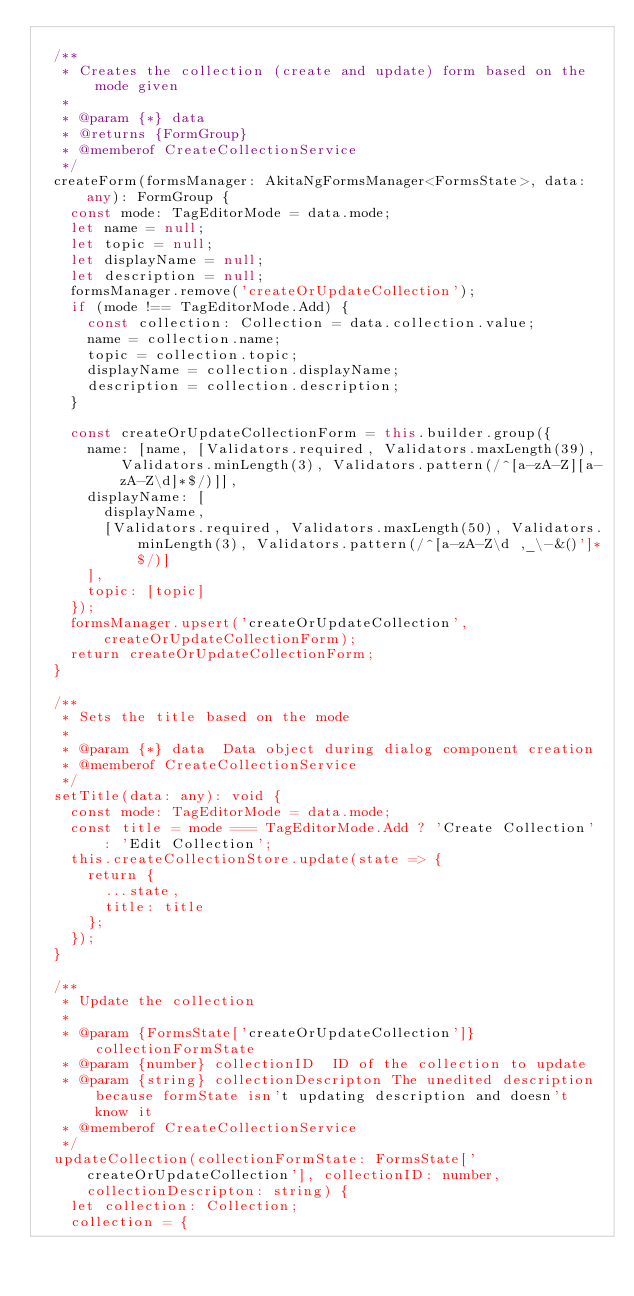<code> <loc_0><loc_0><loc_500><loc_500><_TypeScript_>
  /**
   * Creates the collection (create and update) form based on the mode given
   *
   * @param {*} data
   * @returns {FormGroup}
   * @memberof CreateCollectionService
   */
  createForm(formsManager: AkitaNgFormsManager<FormsState>, data: any): FormGroup {
    const mode: TagEditorMode = data.mode;
    let name = null;
    let topic = null;
    let displayName = null;
    let description = null;
    formsManager.remove('createOrUpdateCollection');
    if (mode !== TagEditorMode.Add) {
      const collection: Collection = data.collection.value;
      name = collection.name;
      topic = collection.topic;
      displayName = collection.displayName;
      description = collection.description;
    }

    const createOrUpdateCollectionForm = this.builder.group({
      name: [name, [Validators.required, Validators.maxLength(39), Validators.minLength(3), Validators.pattern(/^[a-zA-Z][a-zA-Z\d]*$/)]],
      displayName: [
        displayName,
        [Validators.required, Validators.maxLength(50), Validators.minLength(3), Validators.pattern(/^[a-zA-Z\d ,_\-&()']*$/)]
      ],
      topic: [topic]
    });
    formsManager.upsert('createOrUpdateCollection', createOrUpdateCollectionForm);
    return createOrUpdateCollectionForm;
  }

  /**
   * Sets the title based on the mode
   *
   * @param {*} data  Data object during dialog component creation
   * @memberof CreateCollectionService
   */
  setTitle(data: any): void {
    const mode: TagEditorMode = data.mode;
    const title = mode === TagEditorMode.Add ? 'Create Collection' : 'Edit Collection';
    this.createCollectionStore.update(state => {
      return {
        ...state,
        title: title
      };
    });
  }

  /**
   * Update the collection
   *
   * @param {FormsState['createOrUpdateCollection']} collectionFormState
   * @param {number} collectionID  ID of the collection to update
   * @param {string} collectionDescripton The unedited description because formState isn't updating description and doesn't know it
   * @memberof CreateCollectionService
   */
  updateCollection(collectionFormState: FormsState['createOrUpdateCollection'], collectionID: number, collectionDescripton: string) {
    let collection: Collection;
    collection = {</code> 